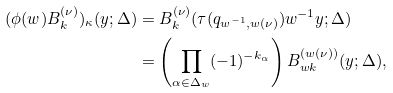Convert formula to latex. <formula><loc_0><loc_0><loc_500><loc_500>( \phi ( w ) B ^ { ( \nu ) } _ { k } ) _ { \kappa } ( y ; \Delta ) & = B ^ { ( \nu ) } _ { k } ( \tau ( q _ { w ^ { - 1 } , w ( \nu ) } ) w ^ { - 1 } y ; \Delta ) \\ & = \left ( \prod _ { \alpha \in \Delta _ { w } } ( - 1 ) ^ { - k _ { \alpha } } \right ) B ^ { ( w ( \nu ) ) } _ { w k } ( y ; \Delta ) ,</formula> 